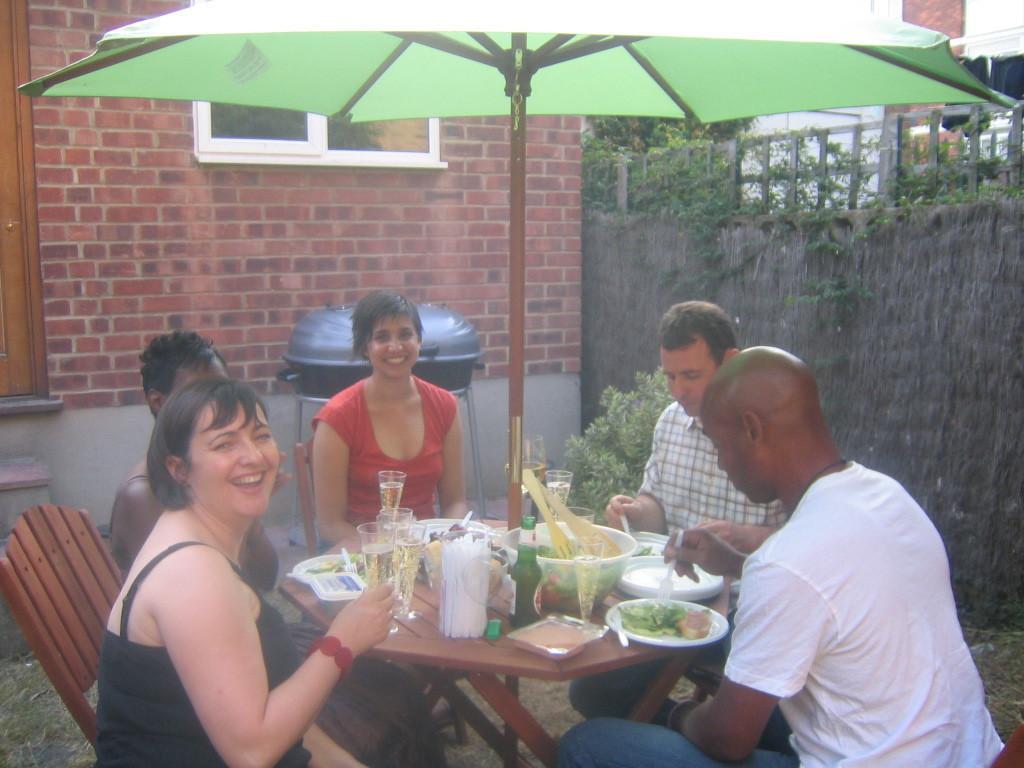How would you summarize this image in a sentence or two? In the center of the image there are people sitting around the table. There are many objects on the table. There is a umbrella. In the background of the image there is a wall. 